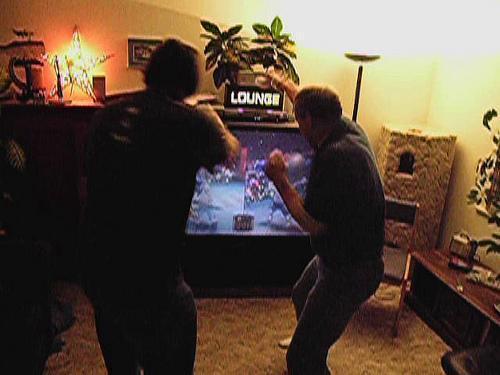How many people are there?
Give a very brief answer. 2. How many people are sitting and relaxing?
Give a very brief answer. 0. 